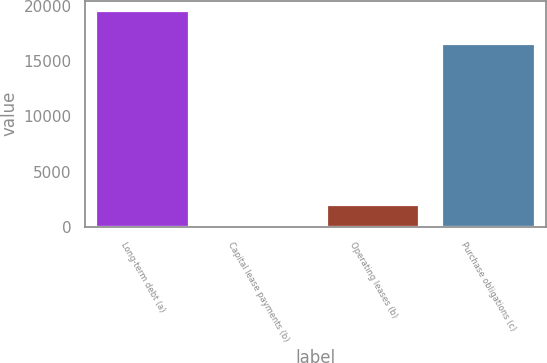Convert chart to OTSL. <chart><loc_0><loc_0><loc_500><loc_500><bar_chart><fcel>Long-term debt (a)<fcel>Capital lease payments (b)<fcel>Operating leases (b)<fcel>Purchase obligations (c)<nl><fcel>19490<fcel>52<fcel>1995.8<fcel>16520<nl></chart> 